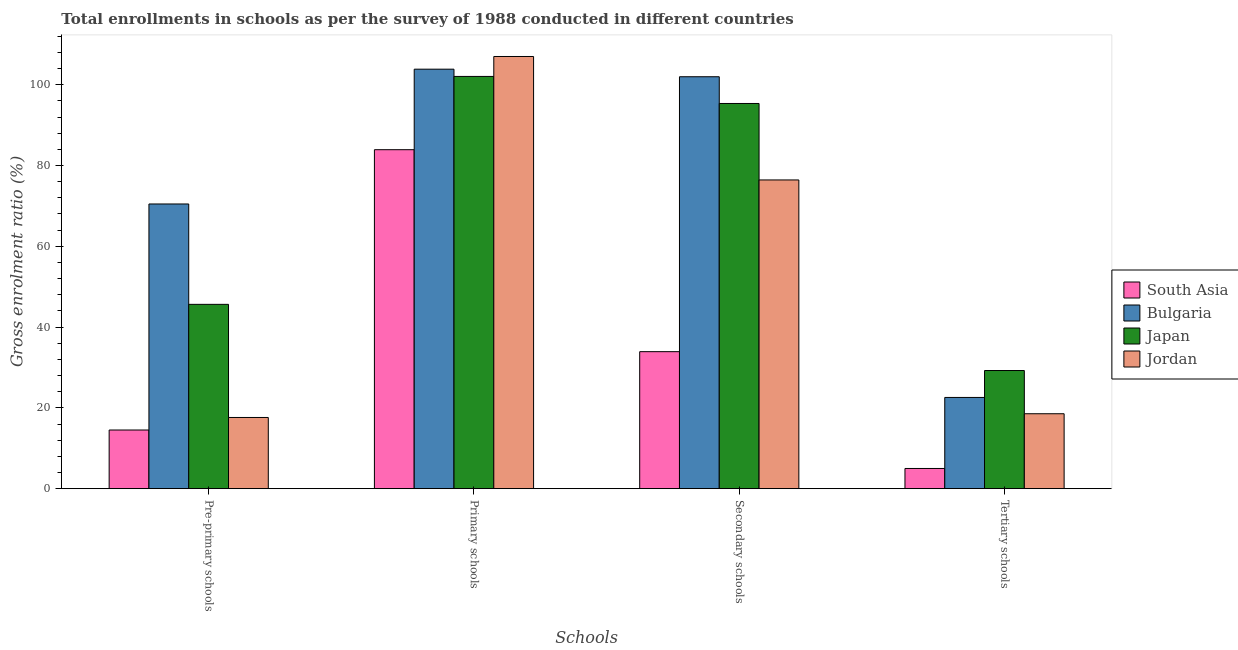How many different coloured bars are there?
Your response must be concise. 4. Are the number of bars per tick equal to the number of legend labels?
Your answer should be very brief. Yes. Are the number of bars on each tick of the X-axis equal?
Ensure brevity in your answer.  Yes. How many bars are there on the 4th tick from the left?
Your answer should be very brief. 4. What is the label of the 4th group of bars from the left?
Provide a short and direct response. Tertiary schools. What is the gross enrolment ratio in tertiary schools in Jordan?
Make the answer very short. 18.55. Across all countries, what is the maximum gross enrolment ratio in tertiary schools?
Your answer should be very brief. 29.25. Across all countries, what is the minimum gross enrolment ratio in pre-primary schools?
Keep it short and to the point. 14.52. In which country was the gross enrolment ratio in secondary schools minimum?
Offer a very short reply. South Asia. What is the total gross enrolment ratio in secondary schools in the graph?
Ensure brevity in your answer.  307.66. What is the difference between the gross enrolment ratio in tertiary schools in Japan and that in Bulgaria?
Your response must be concise. 6.67. What is the difference between the gross enrolment ratio in tertiary schools in Japan and the gross enrolment ratio in secondary schools in South Asia?
Provide a short and direct response. -4.67. What is the average gross enrolment ratio in primary schools per country?
Keep it short and to the point. 99.2. What is the difference between the gross enrolment ratio in secondary schools and gross enrolment ratio in primary schools in Jordan?
Your response must be concise. -30.56. What is the ratio of the gross enrolment ratio in primary schools in South Asia to that in Bulgaria?
Give a very brief answer. 0.81. What is the difference between the highest and the second highest gross enrolment ratio in secondary schools?
Your response must be concise. 6.62. What is the difference between the highest and the lowest gross enrolment ratio in primary schools?
Ensure brevity in your answer.  23.07. Is the sum of the gross enrolment ratio in pre-primary schools in South Asia and Japan greater than the maximum gross enrolment ratio in secondary schools across all countries?
Offer a terse response. No. Is it the case that in every country, the sum of the gross enrolment ratio in tertiary schools and gross enrolment ratio in secondary schools is greater than the sum of gross enrolment ratio in primary schools and gross enrolment ratio in pre-primary schools?
Make the answer very short. No. What does the 2nd bar from the left in Pre-primary schools represents?
Your answer should be compact. Bulgaria. What is the difference between two consecutive major ticks on the Y-axis?
Provide a succinct answer. 20. Are the values on the major ticks of Y-axis written in scientific E-notation?
Your answer should be compact. No. Does the graph contain any zero values?
Your answer should be compact. No. Does the graph contain grids?
Provide a succinct answer. No. How are the legend labels stacked?
Keep it short and to the point. Vertical. What is the title of the graph?
Give a very brief answer. Total enrollments in schools as per the survey of 1988 conducted in different countries. What is the label or title of the X-axis?
Give a very brief answer. Schools. What is the Gross enrolment ratio (%) in South Asia in Pre-primary schools?
Offer a very short reply. 14.52. What is the Gross enrolment ratio (%) of Bulgaria in Pre-primary schools?
Ensure brevity in your answer.  70.47. What is the Gross enrolment ratio (%) of Japan in Pre-primary schools?
Give a very brief answer. 45.63. What is the Gross enrolment ratio (%) in Jordan in Pre-primary schools?
Make the answer very short. 17.63. What is the Gross enrolment ratio (%) of South Asia in Primary schools?
Your response must be concise. 83.91. What is the Gross enrolment ratio (%) of Bulgaria in Primary schools?
Your response must be concise. 103.84. What is the Gross enrolment ratio (%) in Japan in Primary schools?
Offer a terse response. 102.05. What is the Gross enrolment ratio (%) in Jordan in Primary schools?
Your answer should be compact. 106.98. What is the Gross enrolment ratio (%) of South Asia in Secondary schools?
Provide a succinct answer. 33.92. What is the Gross enrolment ratio (%) in Bulgaria in Secondary schools?
Provide a succinct answer. 101.97. What is the Gross enrolment ratio (%) in Japan in Secondary schools?
Ensure brevity in your answer.  95.35. What is the Gross enrolment ratio (%) in Jordan in Secondary schools?
Make the answer very short. 76.42. What is the Gross enrolment ratio (%) of South Asia in Tertiary schools?
Make the answer very short. 5. What is the Gross enrolment ratio (%) of Bulgaria in Tertiary schools?
Offer a terse response. 22.58. What is the Gross enrolment ratio (%) of Japan in Tertiary schools?
Your answer should be compact. 29.25. What is the Gross enrolment ratio (%) in Jordan in Tertiary schools?
Give a very brief answer. 18.55. Across all Schools, what is the maximum Gross enrolment ratio (%) in South Asia?
Give a very brief answer. 83.91. Across all Schools, what is the maximum Gross enrolment ratio (%) of Bulgaria?
Offer a very short reply. 103.84. Across all Schools, what is the maximum Gross enrolment ratio (%) in Japan?
Keep it short and to the point. 102.05. Across all Schools, what is the maximum Gross enrolment ratio (%) of Jordan?
Make the answer very short. 106.98. Across all Schools, what is the minimum Gross enrolment ratio (%) in South Asia?
Your answer should be very brief. 5. Across all Schools, what is the minimum Gross enrolment ratio (%) of Bulgaria?
Offer a terse response. 22.58. Across all Schools, what is the minimum Gross enrolment ratio (%) of Japan?
Keep it short and to the point. 29.25. Across all Schools, what is the minimum Gross enrolment ratio (%) in Jordan?
Provide a short and direct response. 17.63. What is the total Gross enrolment ratio (%) in South Asia in the graph?
Offer a terse response. 137.35. What is the total Gross enrolment ratio (%) in Bulgaria in the graph?
Offer a terse response. 298.87. What is the total Gross enrolment ratio (%) in Japan in the graph?
Offer a terse response. 272.27. What is the total Gross enrolment ratio (%) of Jordan in the graph?
Your response must be concise. 219.58. What is the difference between the Gross enrolment ratio (%) in South Asia in Pre-primary schools and that in Primary schools?
Your answer should be compact. -69.39. What is the difference between the Gross enrolment ratio (%) of Bulgaria in Pre-primary schools and that in Primary schools?
Your answer should be very brief. -33.37. What is the difference between the Gross enrolment ratio (%) of Japan in Pre-primary schools and that in Primary schools?
Ensure brevity in your answer.  -56.42. What is the difference between the Gross enrolment ratio (%) in Jordan in Pre-primary schools and that in Primary schools?
Offer a terse response. -89.36. What is the difference between the Gross enrolment ratio (%) in South Asia in Pre-primary schools and that in Secondary schools?
Ensure brevity in your answer.  -19.4. What is the difference between the Gross enrolment ratio (%) in Bulgaria in Pre-primary schools and that in Secondary schools?
Your answer should be compact. -31.49. What is the difference between the Gross enrolment ratio (%) in Japan in Pre-primary schools and that in Secondary schools?
Offer a very short reply. -49.73. What is the difference between the Gross enrolment ratio (%) of Jordan in Pre-primary schools and that in Secondary schools?
Offer a terse response. -58.79. What is the difference between the Gross enrolment ratio (%) in South Asia in Pre-primary schools and that in Tertiary schools?
Your answer should be compact. 9.52. What is the difference between the Gross enrolment ratio (%) in Bulgaria in Pre-primary schools and that in Tertiary schools?
Offer a terse response. 47.89. What is the difference between the Gross enrolment ratio (%) in Japan in Pre-primary schools and that in Tertiary schools?
Provide a short and direct response. 16.38. What is the difference between the Gross enrolment ratio (%) of Jordan in Pre-primary schools and that in Tertiary schools?
Ensure brevity in your answer.  -0.92. What is the difference between the Gross enrolment ratio (%) in South Asia in Primary schools and that in Secondary schools?
Provide a succinct answer. 49.99. What is the difference between the Gross enrolment ratio (%) of Bulgaria in Primary schools and that in Secondary schools?
Give a very brief answer. 1.87. What is the difference between the Gross enrolment ratio (%) in Japan in Primary schools and that in Secondary schools?
Your response must be concise. 6.69. What is the difference between the Gross enrolment ratio (%) of Jordan in Primary schools and that in Secondary schools?
Give a very brief answer. 30.56. What is the difference between the Gross enrolment ratio (%) in South Asia in Primary schools and that in Tertiary schools?
Offer a terse response. 78.91. What is the difference between the Gross enrolment ratio (%) in Bulgaria in Primary schools and that in Tertiary schools?
Ensure brevity in your answer.  81.26. What is the difference between the Gross enrolment ratio (%) in Japan in Primary schools and that in Tertiary schools?
Your response must be concise. 72.8. What is the difference between the Gross enrolment ratio (%) in Jordan in Primary schools and that in Tertiary schools?
Offer a terse response. 88.44. What is the difference between the Gross enrolment ratio (%) in South Asia in Secondary schools and that in Tertiary schools?
Give a very brief answer. 28.92. What is the difference between the Gross enrolment ratio (%) of Bulgaria in Secondary schools and that in Tertiary schools?
Offer a terse response. 79.39. What is the difference between the Gross enrolment ratio (%) in Japan in Secondary schools and that in Tertiary schools?
Keep it short and to the point. 66.1. What is the difference between the Gross enrolment ratio (%) in Jordan in Secondary schools and that in Tertiary schools?
Keep it short and to the point. 57.87. What is the difference between the Gross enrolment ratio (%) of South Asia in Pre-primary schools and the Gross enrolment ratio (%) of Bulgaria in Primary schools?
Your answer should be compact. -89.32. What is the difference between the Gross enrolment ratio (%) in South Asia in Pre-primary schools and the Gross enrolment ratio (%) in Japan in Primary schools?
Your answer should be very brief. -87.53. What is the difference between the Gross enrolment ratio (%) of South Asia in Pre-primary schools and the Gross enrolment ratio (%) of Jordan in Primary schools?
Make the answer very short. -92.46. What is the difference between the Gross enrolment ratio (%) of Bulgaria in Pre-primary schools and the Gross enrolment ratio (%) of Japan in Primary schools?
Your answer should be very brief. -31.57. What is the difference between the Gross enrolment ratio (%) of Bulgaria in Pre-primary schools and the Gross enrolment ratio (%) of Jordan in Primary schools?
Keep it short and to the point. -36.51. What is the difference between the Gross enrolment ratio (%) in Japan in Pre-primary schools and the Gross enrolment ratio (%) in Jordan in Primary schools?
Give a very brief answer. -61.36. What is the difference between the Gross enrolment ratio (%) in South Asia in Pre-primary schools and the Gross enrolment ratio (%) in Bulgaria in Secondary schools?
Keep it short and to the point. -87.45. What is the difference between the Gross enrolment ratio (%) of South Asia in Pre-primary schools and the Gross enrolment ratio (%) of Japan in Secondary schools?
Your response must be concise. -80.83. What is the difference between the Gross enrolment ratio (%) of South Asia in Pre-primary schools and the Gross enrolment ratio (%) of Jordan in Secondary schools?
Keep it short and to the point. -61.9. What is the difference between the Gross enrolment ratio (%) in Bulgaria in Pre-primary schools and the Gross enrolment ratio (%) in Japan in Secondary schools?
Ensure brevity in your answer.  -24.88. What is the difference between the Gross enrolment ratio (%) in Bulgaria in Pre-primary schools and the Gross enrolment ratio (%) in Jordan in Secondary schools?
Your answer should be very brief. -5.95. What is the difference between the Gross enrolment ratio (%) of Japan in Pre-primary schools and the Gross enrolment ratio (%) of Jordan in Secondary schools?
Provide a succinct answer. -30.8. What is the difference between the Gross enrolment ratio (%) in South Asia in Pre-primary schools and the Gross enrolment ratio (%) in Bulgaria in Tertiary schools?
Ensure brevity in your answer.  -8.06. What is the difference between the Gross enrolment ratio (%) of South Asia in Pre-primary schools and the Gross enrolment ratio (%) of Japan in Tertiary schools?
Give a very brief answer. -14.73. What is the difference between the Gross enrolment ratio (%) in South Asia in Pre-primary schools and the Gross enrolment ratio (%) in Jordan in Tertiary schools?
Keep it short and to the point. -4.03. What is the difference between the Gross enrolment ratio (%) of Bulgaria in Pre-primary schools and the Gross enrolment ratio (%) of Japan in Tertiary schools?
Give a very brief answer. 41.23. What is the difference between the Gross enrolment ratio (%) of Bulgaria in Pre-primary schools and the Gross enrolment ratio (%) of Jordan in Tertiary schools?
Your answer should be very brief. 51.93. What is the difference between the Gross enrolment ratio (%) of Japan in Pre-primary schools and the Gross enrolment ratio (%) of Jordan in Tertiary schools?
Provide a short and direct response. 27.08. What is the difference between the Gross enrolment ratio (%) of South Asia in Primary schools and the Gross enrolment ratio (%) of Bulgaria in Secondary schools?
Your answer should be compact. -18.06. What is the difference between the Gross enrolment ratio (%) in South Asia in Primary schools and the Gross enrolment ratio (%) in Japan in Secondary schools?
Offer a terse response. -11.44. What is the difference between the Gross enrolment ratio (%) in South Asia in Primary schools and the Gross enrolment ratio (%) in Jordan in Secondary schools?
Your answer should be compact. 7.49. What is the difference between the Gross enrolment ratio (%) in Bulgaria in Primary schools and the Gross enrolment ratio (%) in Japan in Secondary schools?
Your answer should be very brief. 8.49. What is the difference between the Gross enrolment ratio (%) in Bulgaria in Primary schools and the Gross enrolment ratio (%) in Jordan in Secondary schools?
Provide a succinct answer. 27.42. What is the difference between the Gross enrolment ratio (%) in Japan in Primary schools and the Gross enrolment ratio (%) in Jordan in Secondary schools?
Ensure brevity in your answer.  25.63. What is the difference between the Gross enrolment ratio (%) in South Asia in Primary schools and the Gross enrolment ratio (%) in Bulgaria in Tertiary schools?
Make the answer very short. 61.33. What is the difference between the Gross enrolment ratio (%) of South Asia in Primary schools and the Gross enrolment ratio (%) of Japan in Tertiary schools?
Keep it short and to the point. 54.66. What is the difference between the Gross enrolment ratio (%) in South Asia in Primary schools and the Gross enrolment ratio (%) in Jordan in Tertiary schools?
Provide a short and direct response. 65.36. What is the difference between the Gross enrolment ratio (%) of Bulgaria in Primary schools and the Gross enrolment ratio (%) of Japan in Tertiary schools?
Your answer should be very brief. 74.59. What is the difference between the Gross enrolment ratio (%) of Bulgaria in Primary schools and the Gross enrolment ratio (%) of Jordan in Tertiary schools?
Offer a very short reply. 85.29. What is the difference between the Gross enrolment ratio (%) of Japan in Primary schools and the Gross enrolment ratio (%) of Jordan in Tertiary schools?
Make the answer very short. 83.5. What is the difference between the Gross enrolment ratio (%) of South Asia in Secondary schools and the Gross enrolment ratio (%) of Bulgaria in Tertiary schools?
Your answer should be compact. 11.33. What is the difference between the Gross enrolment ratio (%) of South Asia in Secondary schools and the Gross enrolment ratio (%) of Japan in Tertiary schools?
Provide a succinct answer. 4.67. What is the difference between the Gross enrolment ratio (%) in South Asia in Secondary schools and the Gross enrolment ratio (%) in Jordan in Tertiary schools?
Offer a terse response. 15.37. What is the difference between the Gross enrolment ratio (%) in Bulgaria in Secondary schools and the Gross enrolment ratio (%) in Japan in Tertiary schools?
Your answer should be compact. 72.72. What is the difference between the Gross enrolment ratio (%) of Bulgaria in Secondary schools and the Gross enrolment ratio (%) of Jordan in Tertiary schools?
Ensure brevity in your answer.  83.42. What is the difference between the Gross enrolment ratio (%) in Japan in Secondary schools and the Gross enrolment ratio (%) in Jordan in Tertiary schools?
Your response must be concise. 76.8. What is the average Gross enrolment ratio (%) in South Asia per Schools?
Provide a succinct answer. 34.34. What is the average Gross enrolment ratio (%) of Bulgaria per Schools?
Your answer should be very brief. 74.72. What is the average Gross enrolment ratio (%) in Japan per Schools?
Your answer should be very brief. 68.07. What is the average Gross enrolment ratio (%) in Jordan per Schools?
Make the answer very short. 54.89. What is the difference between the Gross enrolment ratio (%) of South Asia and Gross enrolment ratio (%) of Bulgaria in Pre-primary schools?
Provide a short and direct response. -55.95. What is the difference between the Gross enrolment ratio (%) of South Asia and Gross enrolment ratio (%) of Japan in Pre-primary schools?
Keep it short and to the point. -31.1. What is the difference between the Gross enrolment ratio (%) of South Asia and Gross enrolment ratio (%) of Jordan in Pre-primary schools?
Your response must be concise. -3.1. What is the difference between the Gross enrolment ratio (%) in Bulgaria and Gross enrolment ratio (%) in Japan in Pre-primary schools?
Keep it short and to the point. 24.85. What is the difference between the Gross enrolment ratio (%) of Bulgaria and Gross enrolment ratio (%) of Jordan in Pre-primary schools?
Your answer should be compact. 52.85. What is the difference between the Gross enrolment ratio (%) in Japan and Gross enrolment ratio (%) in Jordan in Pre-primary schools?
Provide a succinct answer. 28. What is the difference between the Gross enrolment ratio (%) of South Asia and Gross enrolment ratio (%) of Bulgaria in Primary schools?
Ensure brevity in your answer.  -19.93. What is the difference between the Gross enrolment ratio (%) in South Asia and Gross enrolment ratio (%) in Japan in Primary schools?
Ensure brevity in your answer.  -18.14. What is the difference between the Gross enrolment ratio (%) of South Asia and Gross enrolment ratio (%) of Jordan in Primary schools?
Provide a succinct answer. -23.07. What is the difference between the Gross enrolment ratio (%) in Bulgaria and Gross enrolment ratio (%) in Japan in Primary schools?
Provide a short and direct response. 1.8. What is the difference between the Gross enrolment ratio (%) in Bulgaria and Gross enrolment ratio (%) in Jordan in Primary schools?
Your answer should be compact. -3.14. What is the difference between the Gross enrolment ratio (%) in Japan and Gross enrolment ratio (%) in Jordan in Primary schools?
Your answer should be compact. -4.94. What is the difference between the Gross enrolment ratio (%) of South Asia and Gross enrolment ratio (%) of Bulgaria in Secondary schools?
Offer a terse response. -68.05. What is the difference between the Gross enrolment ratio (%) in South Asia and Gross enrolment ratio (%) in Japan in Secondary schools?
Give a very brief answer. -61.44. What is the difference between the Gross enrolment ratio (%) in South Asia and Gross enrolment ratio (%) in Jordan in Secondary schools?
Make the answer very short. -42.5. What is the difference between the Gross enrolment ratio (%) of Bulgaria and Gross enrolment ratio (%) of Japan in Secondary schools?
Offer a terse response. 6.62. What is the difference between the Gross enrolment ratio (%) in Bulgaria and Gross enrolment ratio (%) in Jordan in Secondary schools?
Provide a short and direct response. 25.55. What is the difference between the Gross enrolment ratio (%) in Japan and Gross enrolment ratio (%) in Jordan in Secondary schools?
Provide a short and direct response. 18.93. What is the difference between the Gross enrolment ratio (%) of South Asia and Gross enrolment ratio (%) of Bulgaria in Tertiary schools?
Your response must be concise. -17.58. What is the difference between the Gross enrolment ratio (%) in South Asia and Gross enrolment ratio (%) in Japan in Tertiary schools?
Ensure brevity in your answer.  -24.25. What is the difference between the Gross enrolment ratio (%) of South Asia and Gross enrolment ratio (%) of Jordan in Tertiary schools?
Offer a terse response. -13.55. What is the difference between the Gross enrolment ratio (%) in Bulgaria and Gross enrolment ratio (%) in Japan in Tertiary schools?
Provide a succinct answer. -6.67. What is the difference between the Gross enrolment ratio (%) in Bulgaria and Gross enrolment ratio (%) in Jordan in Tertiary schools?
Ensure brevity in your answer.  4.03. What is the difference between the Gross enrolment ratio (%) of Japan and Gross enrolment ratio (%) of Jordan in Tertiary schools?
Offer a terse response. 10.7. What is the ratio of the Gross enrolment ratio (%) of South Asia in Pre-primary schools to that in Primary schools?
Offer a very short reply. 0.17. What is the ratio of the Gross enrolment ratio (%) of Bulgaria in Pre-primary schools to that in Primary schools?
Your response must be concise. 0.68. What is the ratio of the Gross enrolment ratio (%) of Japan in Pre-primary schools to that in Primary schools?
Provide a succinct answer. 0.45. What is the ratio of the Gross enrolment ratio (%) of Jordan in Pre-primary schools to that in Primary schools?
Offer a very short reply. 0.16. What is the ratio of the Gross enrolment ratio (%) in South Asia in Pre-primary schools to that in Secondary schools?
Ensure brevity in your answer.  0.43. What is the ratio of the Gross enrolment ratio (%) in Bulgaria in Pre-primary schools to that in Secondary schools?
Your answer should be compact. 0.69. What is the ratio of the Gross enrolment ratio (%) of Japan in Pre-primary schools to that in Secondary schools?
Provide a succinct answer. 0.48. What is the ratio of the Gross enrolment ratio (%) of Jordan in Pre-primary schools to that in Secondary schools?
Provide a short and direct response. 0.23. What is the ratio of the Gross enrolment ratio (%) in South Asia in Pre-primary schools to that in Tertiary schools?
Offer a terse response. 2.9. What is the ratio of the Gross enrolment ratio (%) of Bulgaria in Pre-primary schools to that in Tertiary schools?
Your answer should be very brief. 3.12. What is the ratio of the Gross enrolment ratio (%) in Japan in Pre-primary schools to that in Tertiary schools?
Offer a very short reply. 1.56. What is the ratio of the Gross enrolment ratio (%) in Jordan in Pre-primary schools to that in Tertiary schools?
Provide a short and direct response. 0.95. What is the ratio of the Gross enrolment ratio (%) of South Asia in Primary schools to that in Secondary schools?
Your answer should be compact. 2.47. What is the ratio of the Gross enrolment ratio (%) in Bulgaria in Primary schools to that in Secondary schools?
Give a very brief answer. 1.02. What is the ratio of the Gross enrolment ratio (%) in Japan in Primary schools to that in Secondary schools?
Give a very brief answer. 1.07. What is the ratio of the Gross enrolment ratio (%) in Jordan in Primary schools to that in Secondary schools?
Offer a terse response. 1.4. What is the ratio of the Gross enrolment ratio (%) in South Asia in Primary schools to that in Tertiary schools?
Make the answer very short. 16.78. What is the ratio of the Gross enrolment ratio (%) in Bulgaria in Primary schools to that in Tertiary schools?
Keep it short and to the point. 4.6. What is the ratio of the Gross enrolment ratio (%) in Japan in Primary schools to that in Tertiary schools?
Provide a short and direct response. 3.49. What is the ratio of the Gross enrolment ratio (%) in Jordan in Primary schools to that in Tertiary schools?
Provide a succinct answer. 5.77. What is the ratio of the Gross enrolment ratio (%) of South Asia in Secondary schools to that in Tertiary schools?
Your response must be concise. 6.78. What is the ratio of the Gross enrolment ratio (%) in Bulgaria in Secondary schools to that in Tertiary schools?
Offer a very short reply. 4.52. What is the ratio of the Gross enrolment ratio (%) of Japan in Secondary schools to that in Tertiary schools?
Offer a very short reply. 3.26. What is the ratio of the Gross enrolment ratio (%) of Jordan in Secondary schools to that in Tertiary schools?
Ensure brevity in your answer.  4.12. What is the difference between the highest and the second highest Gross enrolment ratio (%) in South Asia?
Your answer should be compact. 49.99. What is the difference between the highest and the second highest Gross enrolment ratio (%) in Bulgaria?
Keep it short and to the point. 1.87. What is the difference between the highest and the second highest Gross enrolment ratio (%) in Japan?
Make the answer very short. 6.69. What is the difference between the highest and the second highest Gross enrolment ratio (%) of Jordan?
Provide a short and direct response. 30.56. What is the difference between the highest and the lowest Gross enrolment ratio (%) of South Asia?
Offer a very short reply. 78.91. What is the difference between the highest and the lowest Gross enrolment ratio (%) in Bulgaria?
Your answer should be compact. 81.26. What is the difference between the highest and the lowest Gross enrolment ratio (%) of Japan?
Your response must be concise. 72.8. What is the difference between the highest and the lowest Gross enrolment ratio (%) in Jordan?
Provide a short and direct response. 89.36. 